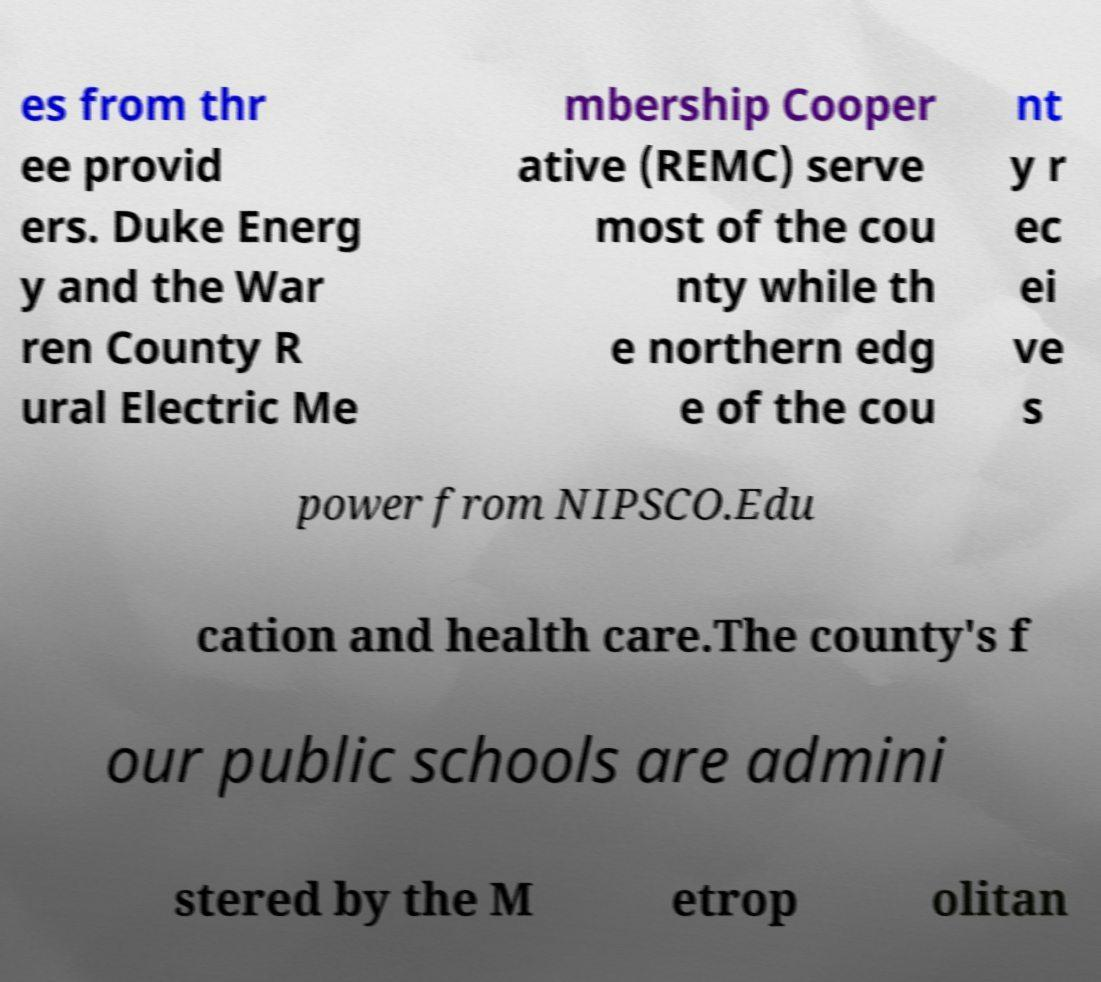There's text embedded in this image that I need extracted. Can you transcribe it verbatim? es from thr ee provid ers. Duke Energ y and the War ren County R ural Electric Me mbership Cooper ative (REMC) serve most of the cou nty while th e northern edg e of the cou nt y r ec ei ve s power from NIPSCO.Edu cation and health care.The county's f our public schools are admini stered by the M etrop olitan 